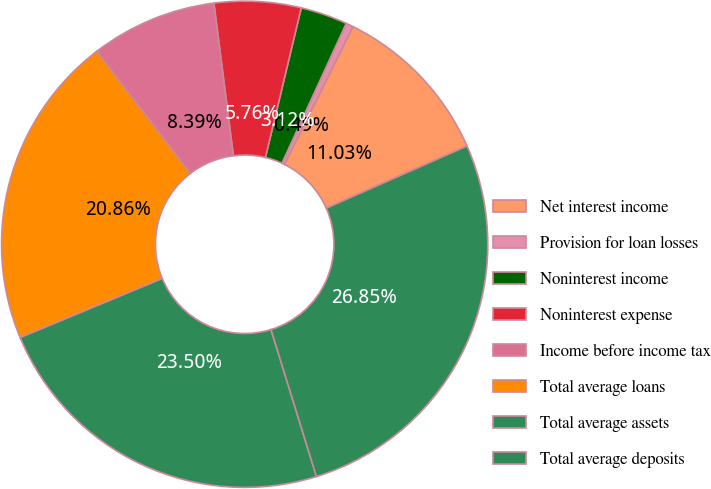<chart> <loc_0><loc_0><loc_500><loc_500><pie_chart><fcel>Net interest income<fcel>Provision for loan losses<fcel>Noninterest income<fcel>Noninterest expense<fcel>Income before income tax<fcel>Total average loans<fcel>Total average assets<fcel>Total average deposits<nl><fcel>11.03%<fcel>0.49%<fcel>3.12%<fcel>5.76%<fcel>8.39%<fcel>20.86%<fcel>23.5%<fcel>26.85%<nl></chart> 